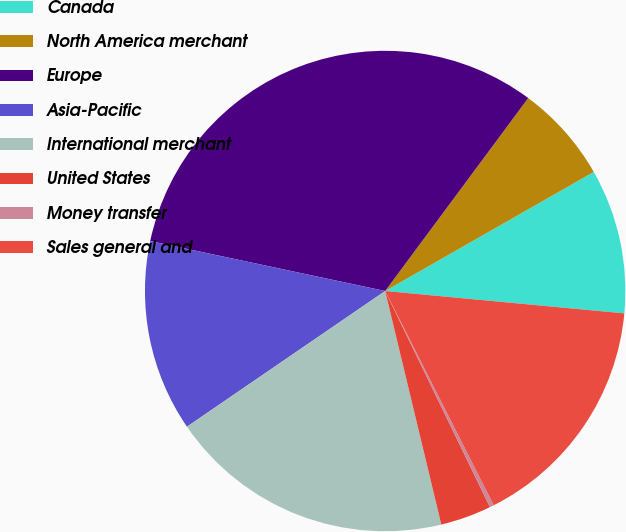Convert chart to OTSL. <chart><loc_0><loc_0><loc_500><loc_500><pie_chart><fcel>Canada<fcel>North America merchant<fcel>Europe<fcel>Asia-Pacific<fcel>International merchant<fcel>United States<fcel>Money transfer<fcel>Sales general and<nl><fcel>9.74%<fcel>6.59%<fcel>31.82%<fcel>12.89%<fcel>19.2%<fcel>3.43%<fcel>0.28%<fcel>16.05%<nl></chart> 